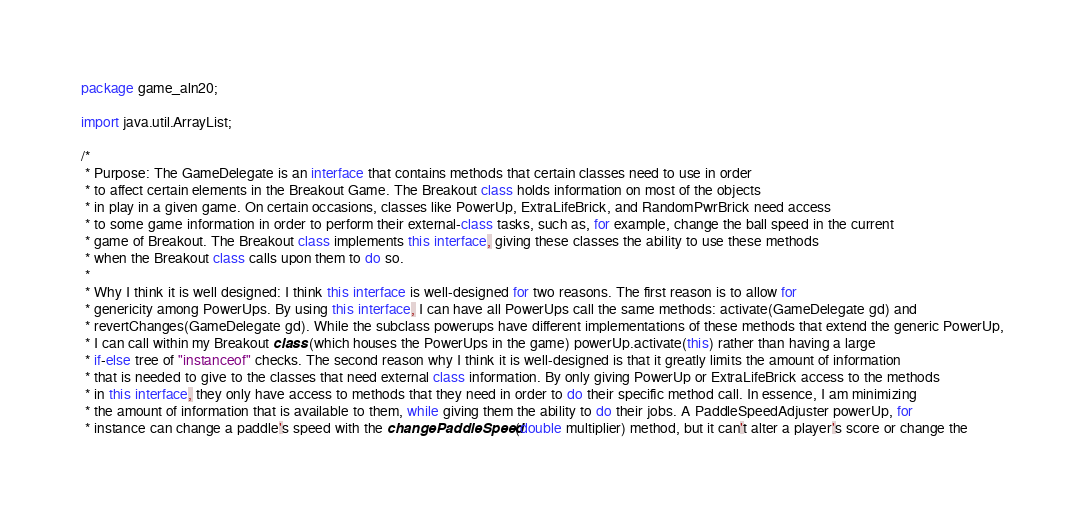Convert code to text. <code><loc_0><loc_0><loc_500><loc_500><_Java_>package game_aln20;

import java.util.ArrayList;

/*
 * Purpose: The GameDelegate is an interface that contains methods that certain classes need to use in order
 * to affect certain elements in the Breakout Game. The Breakout class holds information on most of the objects
 * in play in a given game. On certain occasions, classes like PowerUp, ExtraLifeBrick, and RandomPwrBrick need access 
 * to some game information in order to perform their external-class tasks, such as, for example, change the ball speed in the current
 * game of Breakout. The Breakout class implements this interface, giving these classes the ability to use these methods
 * when the Breakout class calls upon them to do so.
 * 
 * Why I think it is well designed: I think this interface is well-designed for two reasons. The first reason is to allow for
 * genericity among PowerUps. By using this interface, I can have all PowerUps call the same methods: activate(GameDelegate gd) and
 * revertChanges(GameDelegate gd). While the subclass powerups have different implementations of these methods that extend the generic PowerUp,
 * I can call within my Breakout class (which houses the PowerUps in the game) powerUp.activate(this) rather than having a large
 * if-else tree of "instanceof" checks. The second reason why I think it is well-designed is that it greatly limits the amount of information
 * that is needed to give to the classes that need external class information. By only giving PowerUp or ExtraLifeBrick access to the methods
 * in this interface, they only have access to methods that they need in order to do their specific method call. In essence, I am minimizing
 * the amount of information that is available to them, while giving them the ability to do their jobs. A PaddleSpeedAdjuster powerUp, for 
 * instance can change a paddle's speed with the changePaddleSpeed(double multiplier) method, but it can't alter a player's score or change the </code> 